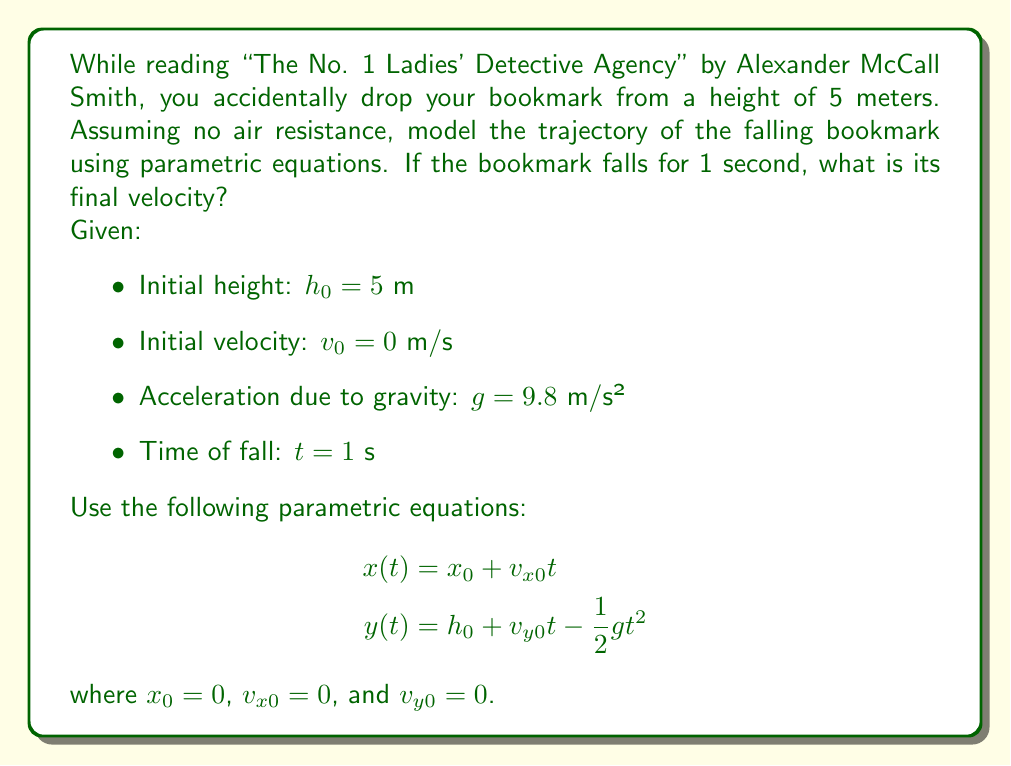Could you help me with this problem? To solve this problem, we'll follow these steps:

1. Identify the relevant parametric equations:
   For vertical motion (y-axis):
   $$y(t) = h_0 + v_{y0}t - \frac{1}{2}gt^2$$

2. Substitute the given values:
   $$y(t) = 5 + 0 \cdot t - \frac{1}{2} \cdot 9.8 \cdot t^2$$
   $$y(t) = 5 - 4.9t^2$$

3. To find the final velocity, we need to use the equation:
   $$v_y(t) = v_{y0} - gt$$

4. Substitute the values:
   $$v_y(t) = 0 - 9.8t$$
   $$v_y(t) = -9.8t$$

5. Calculate the final velocity at t = 1 second:
   $$v_y(1) = -9.8 \cdot 1 = -9.8 \text{ m/s}$$

The negative sign indicates that the bookmark is moving downward.
Answer: The final velocity of the falling bookmark after 1 second is $-9.8 \text{ m/s}$. 